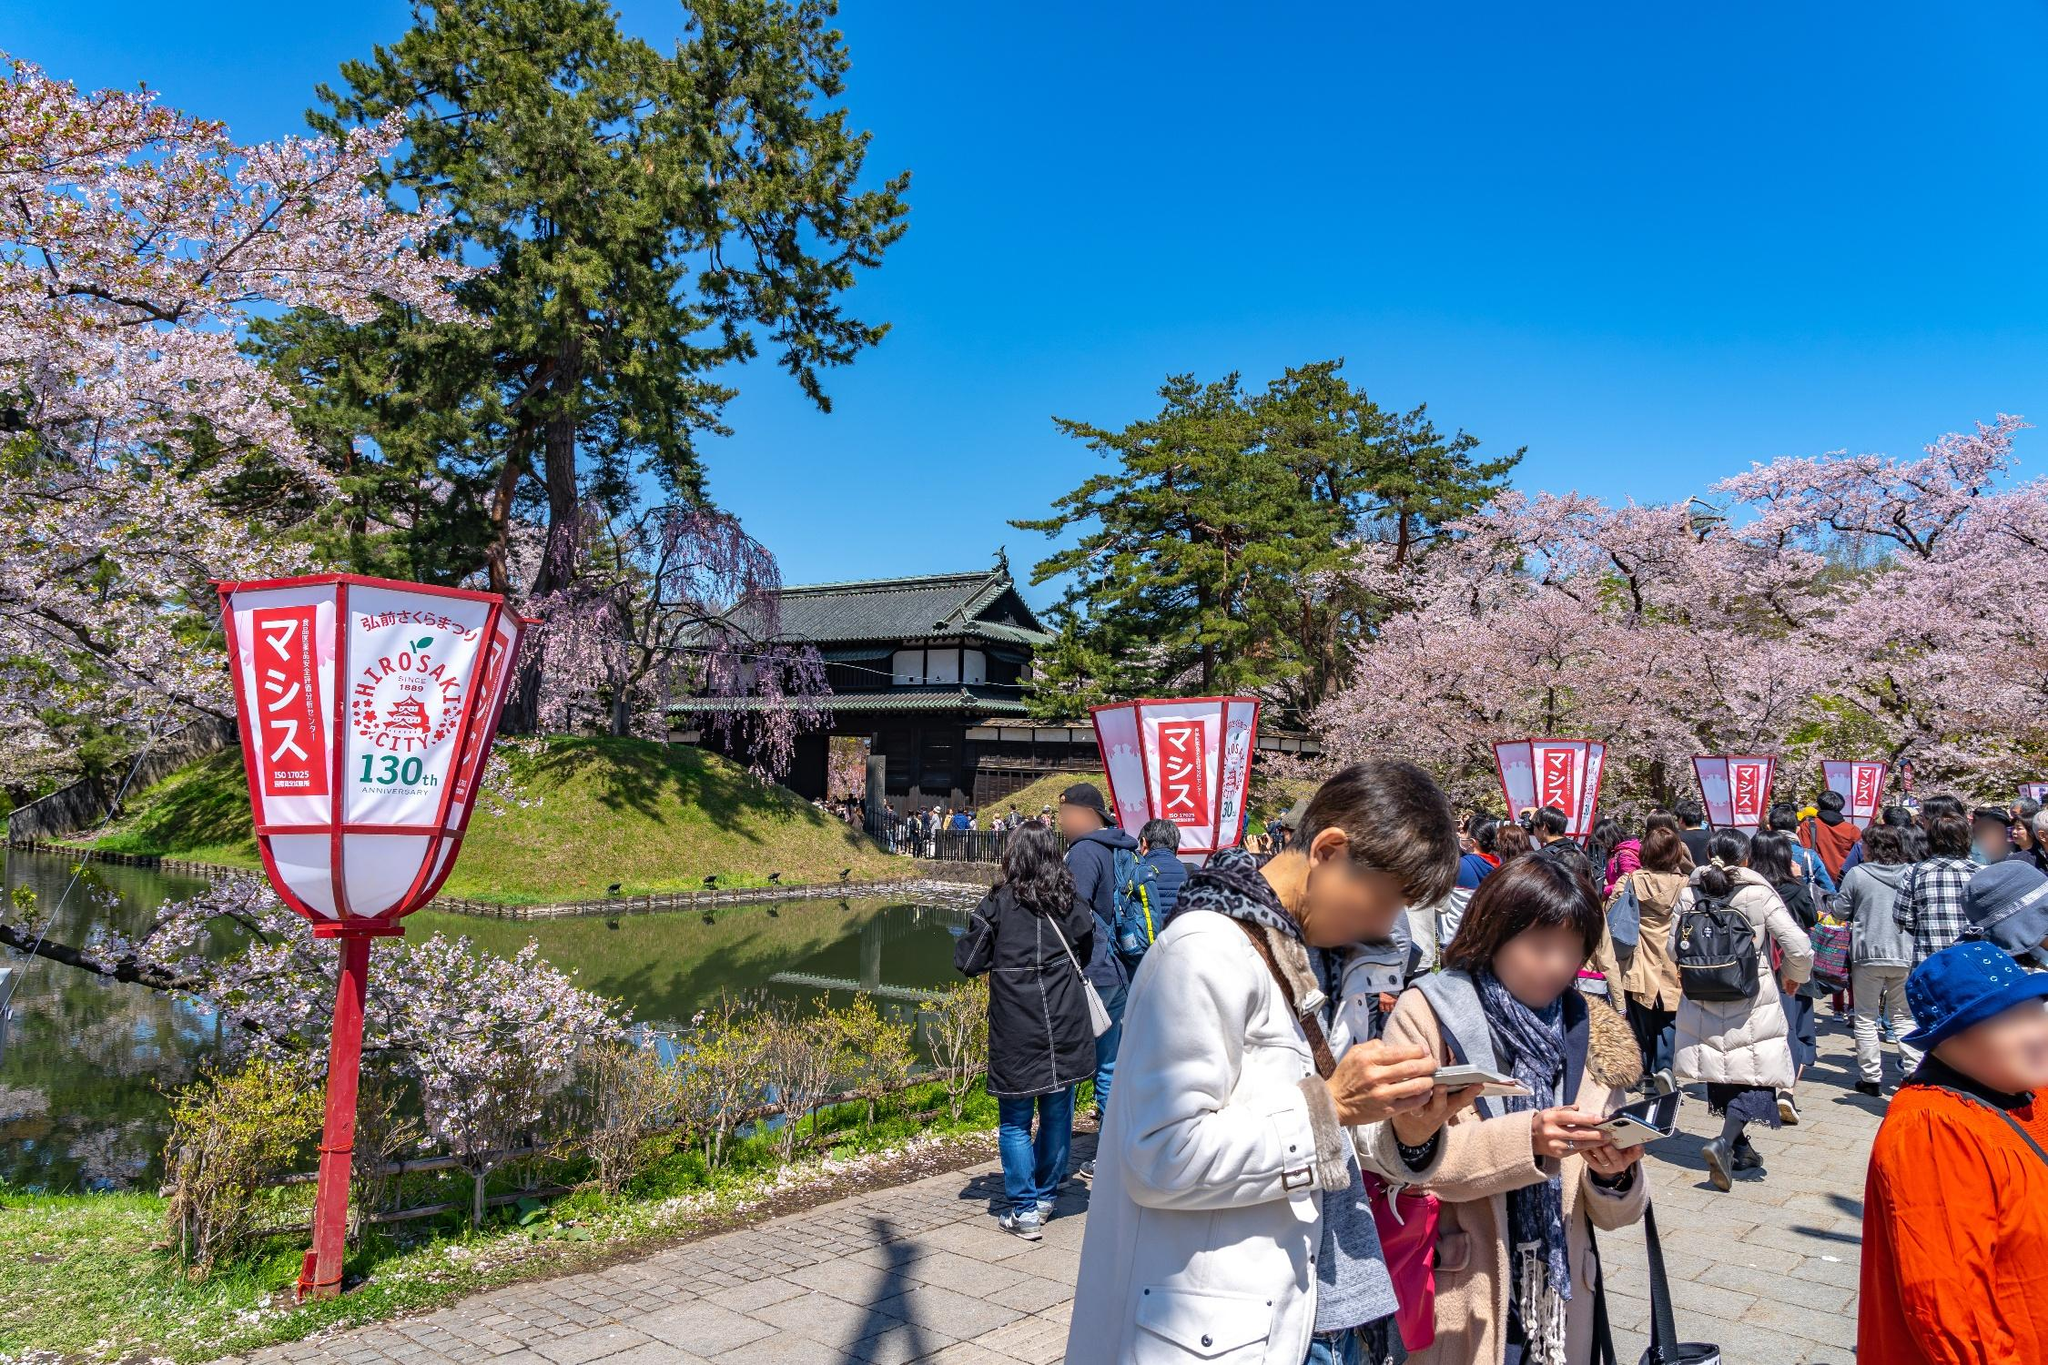Create a short dialogue that might occur between two visitors discussing the cherry blossoms. Visitor 1: "Aren't these cherry blossoms just breathtaking? The whole place feels so magical."
Visitor 2: "Absolutely! I love how the petals almost look like pink snowflakes. It’s my first time here, and I can't believe how beautiful it is."
Visitor 1: "I know, right? The castle as a backdrop makes it even more stunning. And these lanterns add such a traditional touch."
Visitor 2: "Totally! Let's grab some dango and enjoy the view from the other side of the moat." 